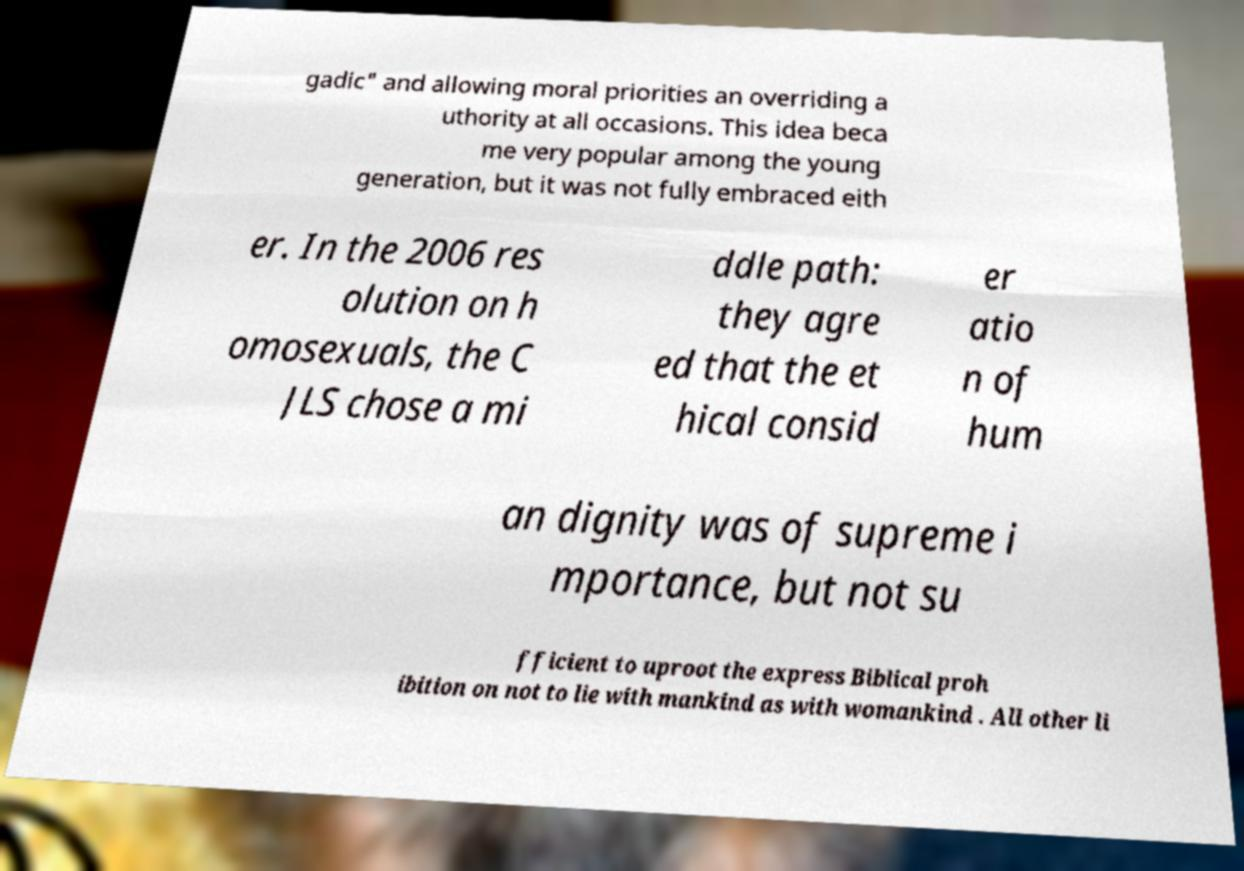Could you assist in decoding the text presented in this image and type it out clearly? gadic" and allowing moral priorities an overriding a uthority at all occasions. This idea beca me very popular among the young generation, but it was not fully embraced eith er. In the 2006 res olution on h omosexuals, the C JLS chose a mi ddle path: they agre ed that the et hical consid er atio n of hum an dignity was of supreme i mportance, but not su fficient to uproot the express Biblical proh ibition on not to lie with mankind as with womankind . All other li 